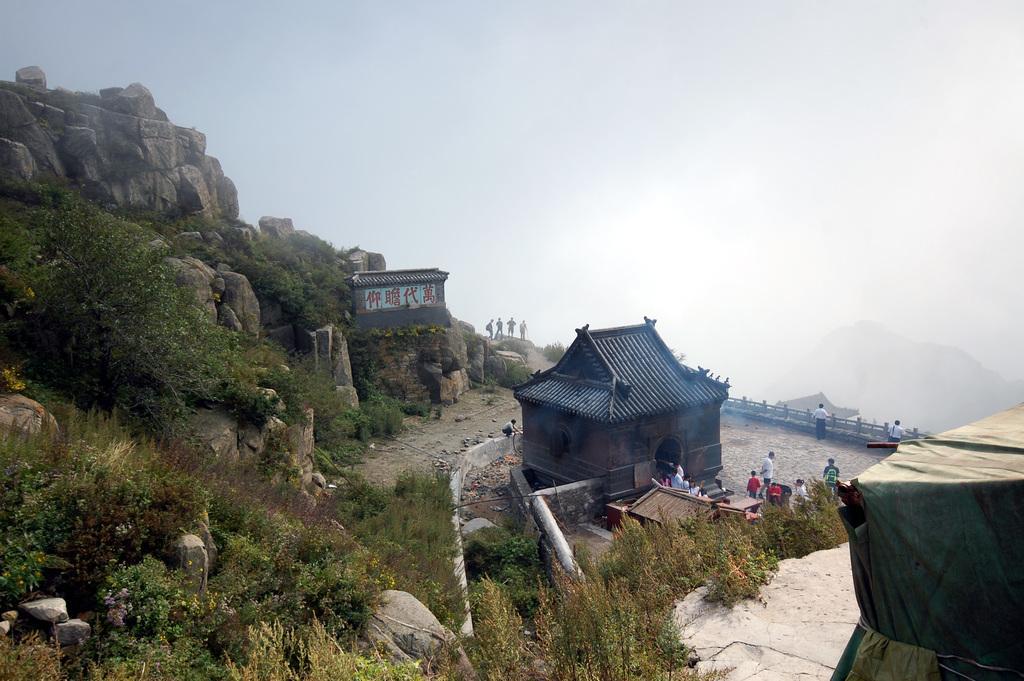Can you describe this image briefly? In this image I can see a house, a tent, a mountain, few trees on the mountain, few persons standing and the railing. In the background I can see a mountain and the sky. 